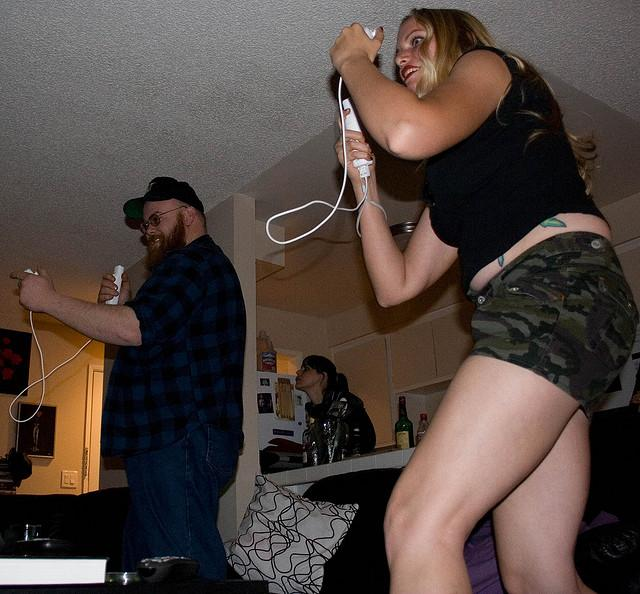What video game console is being played by the two people in front?

Choices:
A) ps5
B) nintendo wii
C) steambox
D) xbox nintendo wii 